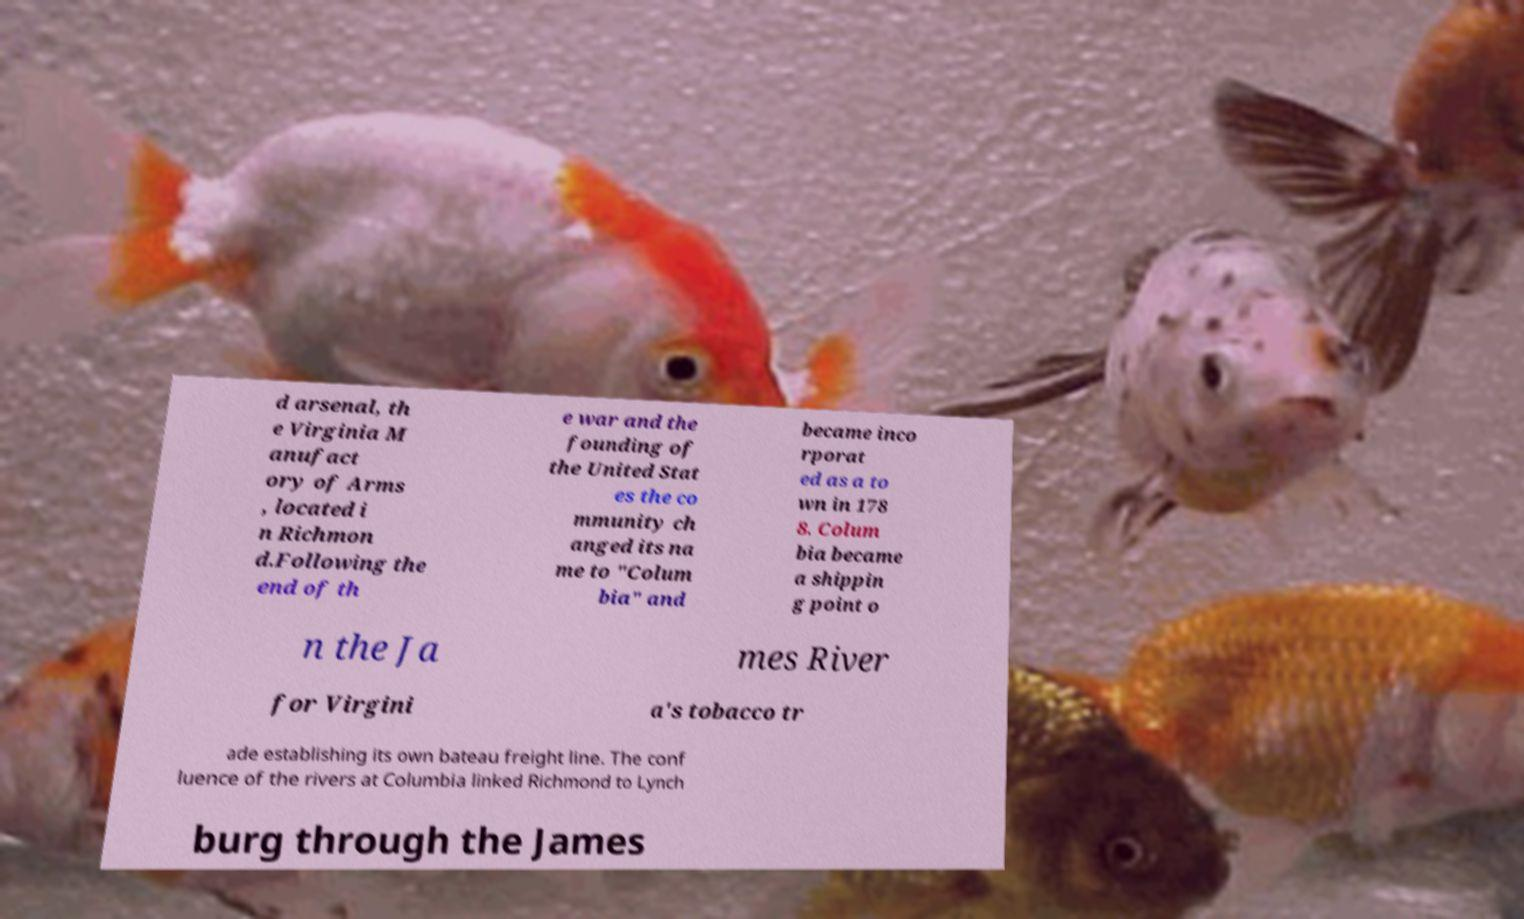I need the written content from this picture converted into text. Can you do that? d arsenal, th e Virginia M anufact ory of Arms , located i n Richmon d.Following the end of th e war and the founding of the United Stat es the co mmunity ch anged its na me to "Colum bia" and became inco rporat ed as a to wn in 178 8. Colum bia became a shippin g point o n the Ja mes River for Virgini a's tobacco tr ade establishing its own bateau freight line. The conf luence of the rivers at Columbia linked Richmond to Lynch burg through the James 